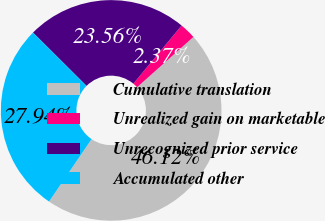<chart> <loc_0><loc_0><loc_500><loc_500><pie_chart><fcel>Cumulative translation<fcel>Unrealized gain on marketable<fcel>Unrecognized prior service<fcel>Accumulated other<nl><fcel>46.12%<fcel>2.37%<fcel>23.56%<fcel>27.94%<nl></chart> 